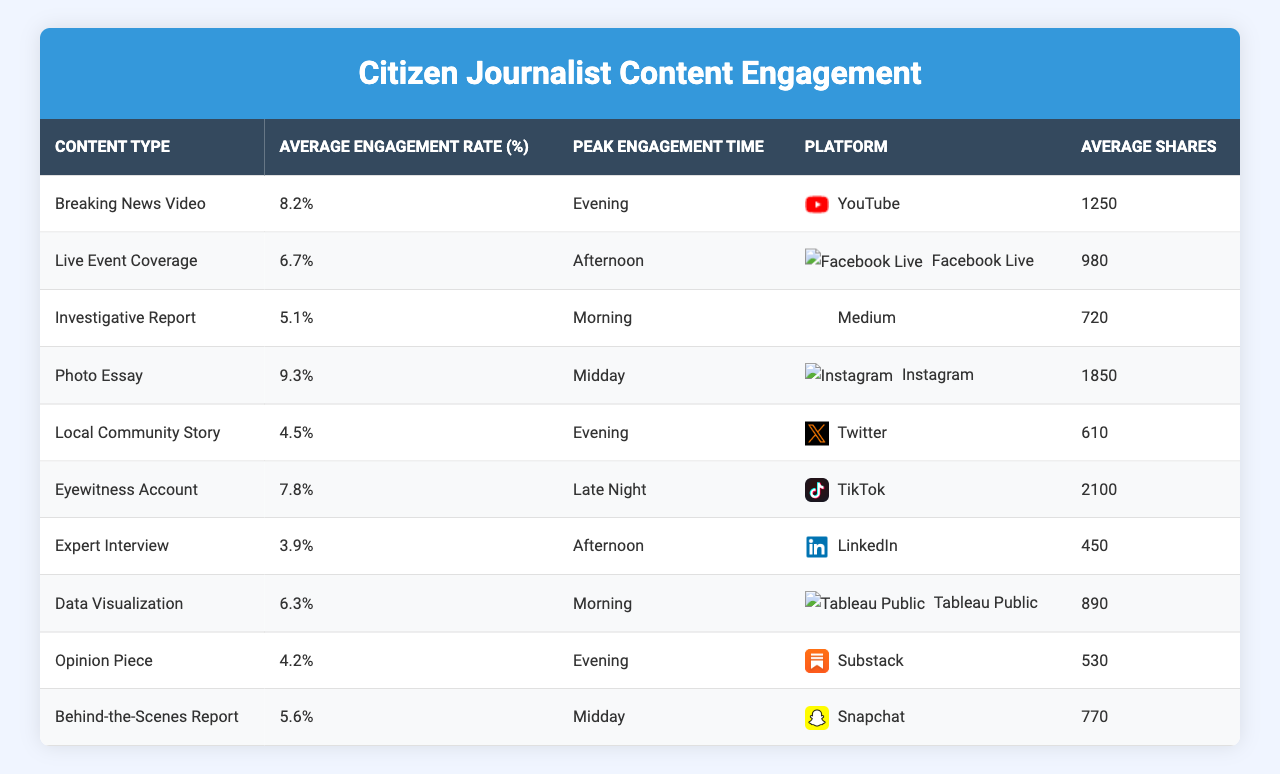What is the average engagement rate for photo essays? From the table, the average engagement rate for photo essays is listed directly under the "Average Engagement Rate (%)" column for that content type, which is 9.3%.
Answer: 9.3% Which content type has the peak engagement time in the evening? By reviewing the "Peak Engagement Time" column, the "Breaking News Video" and "Local Community Story" are both listed under the evening category.
Answer: Breaking News Video and Local Community Story What is the average engagement rate for live event coverage? From the table under the "Average Engagement Rate (%)" column, live event coverage has an engagement rate of 6.7%.
Answer: 6.7% Which content type on Instagram has the highest average shares? The table indicates that the "Photo Essay" on Instagram has 1850 average shares, the highest among all listed.
Answer: Photo Essay Is the average engagement rate for Eyewitness Accounts higher than that for Expert Interviews? The average engagement rate for Eyewitness Accounts is 7.8%, while for Expert Interviews, it is 3.9%. Since 7.8% is greater than 3.9%, the statement is true.
Answer: Yes What is the difference in average engagement rates between Breaking News Video and Investigative Report? The average engagement rate for Breaking News Video is 8.2%, while for Investigative Report, it is 5.1%. The difference is 8.2% - 5.1% = 3.1%.
Answer: 3.1% If we average the engagement rates for all types of content listed in the table, what would it be? Adding all the engagement rates: 8.2 + 6.7 + 5.1 + 9.3 + 4.5 + 7.8 + 3.9 + 6.3 + 4.2 + 5.6 = 57.6. There are 10 content types, so the average is 57.6 / 10 = 5.76%.
Answer: 5.76% Which platform has the highest average shares for its content? The "Eyewitness Account" content type on TikTok has the highest average shares recorded at 2100, which is the largest value in the "Average Shares" column.
Answer: TikTok Is there any content type that has both the highest average engagement rate and peak engagement time of midday? The "Photo Essay" has the highest average engagement rate of 9.3% and the peak engagement time is also listed as midday. This satisfies both conditions.
Answer: Yes How many engagement rates are below 6% in the table? Inspecting the "Average Engagement Rate (%)" column, the following engagement rates are below 6%: 5.1%, 4.5%, 3.9%, and 4.2%. That's four content types below 6%.
Answer: 4 